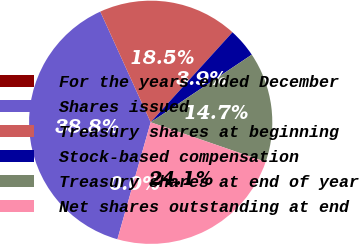Convert chart. <chart><loc_0><loc_0><loc_500><loc_500><pie_chart><fcel>For the years ended December<fcel>Shares issued<fcel>Treasury shares at beginning<fcel>Stock-based compensation<fcel>Treasury shares at end of year<fcel>Net shares outstanding at end<nl><fcel>0.0%<fcel>38.79%<fcel>18.54%<fcel>3.88%<fcel>14.66%<fcel>24.13%<nl></chart> 